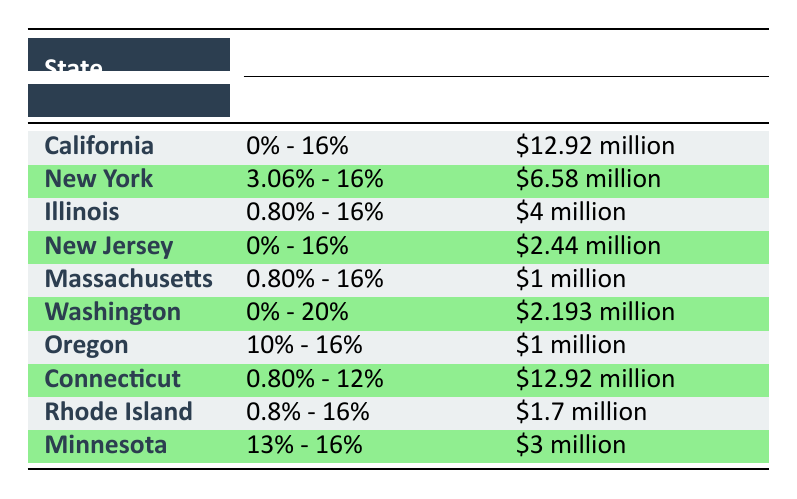What is the estate tax rate range for New York? The table lists New York's estate tax rate as 3.06% - 16%. This information can be found by locating the row corresponding to the state of New York in the "Tax Rate" column.
Answer: 3.06% - 16% Which state has the highest exemption amount? The table indicates that California and Connecticut both have an exemption amount of $12.92 million. By comparing the "Exemption Amount" column, we see California and Connecticut tied for the highest value.
Answer: California and Connecticut Is the estate tax rate for Illinois higher than that for New Jersey? The estate tax rate for Illinois is 0.80% - 16%, while for New Jersey it is 0% - 16%. After analyzing the ranges, since both share the maximum rate of 16% but Illinois has a minimum rate higher than New Jersey, we can conclude that Illinois's rate does indeed include higher values.
Answer: Yes What is the average exemption amount for the states listed? First, we convert each exemption amount into numerical values: $12.92 million, $6.58 million, $4 million, $2.44 million, $1 million, $2.193 million, $1 million, $12.92 million, $1.7 million, and $3 million. Adding these values gives us $48.924 million. With 10 states total, we calculate the average by dividing the total by 10:  $48.924 million / 10 = $4.8924 million.
Answer: $4.8924 million Does Oregon have both the lowest minimum tax rate and the lowest exemption amount? Upon reviewing the table, Oregon's minimum tax rate is 10%, while other states have lower minimums (e.g., New Jersey and Illinois with 0% and 0.80%, respectively). As for the exemption amount, Oregon's is $1 million, which is lower than several other states. Therefore, while it does have a low exemption amount, it does not have the lowest minimum tax rate.
Answer: No Which state has the highest maximum estate tax rate? The maximum estate tax rate is found by examining the "Tax Rate" column. The table shows Washington having a maximum tax rate of 20%, which is higher than other states with a maximum of 16%. Therefore, Washington holds the highest maximum estate tax rate.
Answer: Washington 